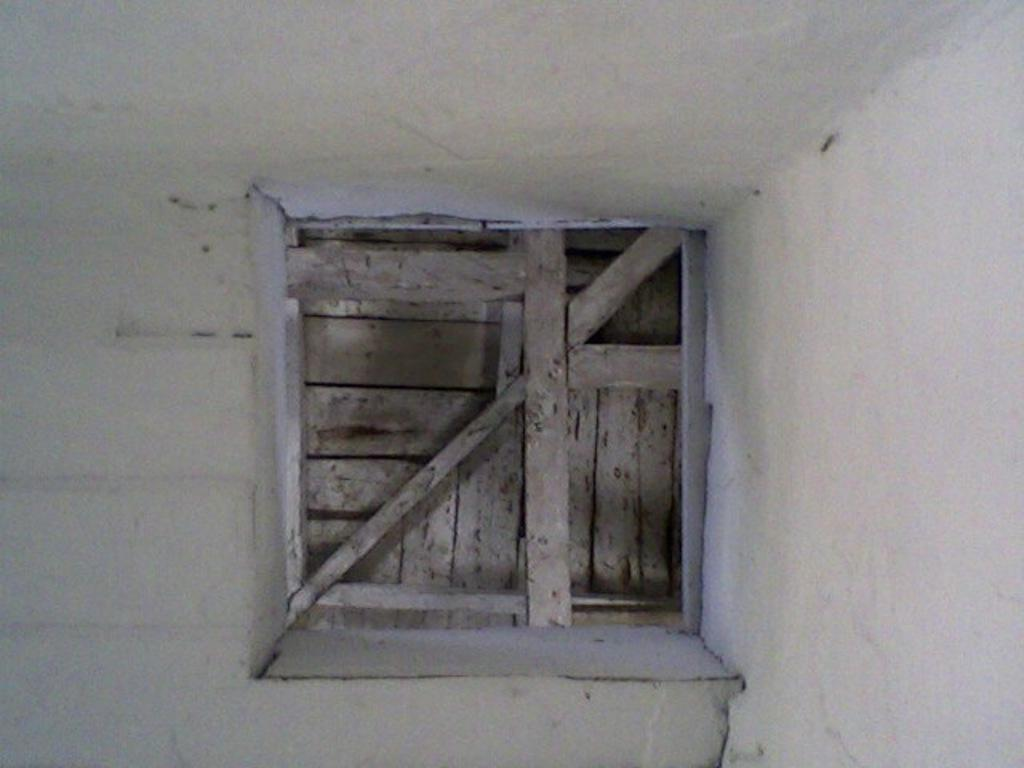What can be seen in the image that provides a view or access to the outdoors? There is a window in the image. How is the window currently positioned or secured? The window is closed with wood. How many pages are being turned in the image? There are no pages present in the image, as it only features a window closed with wood. 